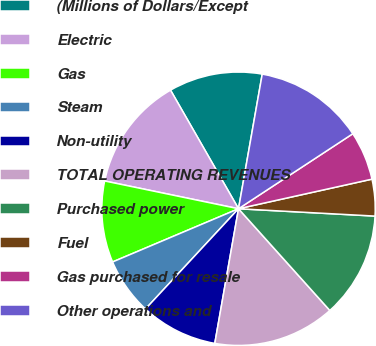Convert chart. <chart><loc_0><loc_0><loc_500><loc_500><pie_chart><fcel>(Millions of Dollars/Except<fcel>Electric<fcel>Gas<fcel>Steam<fcel>Non-utility<fcel>TOTAL OPERATING REVENUES<fcel>Purchased power<fcel>Fuel<fcel>Gas purchased for resale<fcel>Other operations and<nl><fcel>11.06%<fcel>13.46%<fcel>9.62%<fcel>6.73%<fcel>9.13%<fcel>14.42%<fcel>12.5%<fcel>4.33%<fcel>5.77%<fcel>12.98%<nl></chart> 